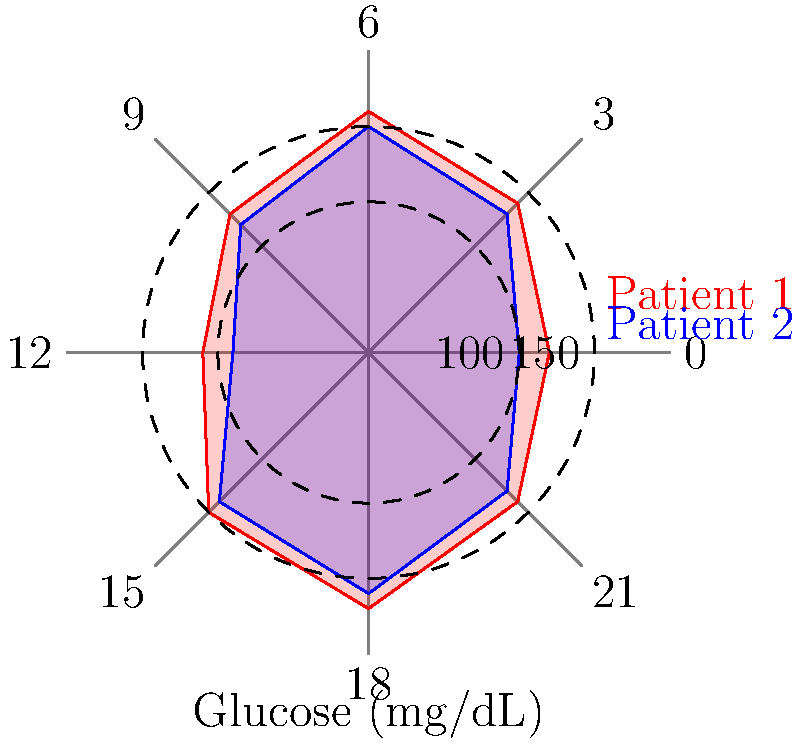As a computer science student helping patients set up health monitoring devices, you're tasked with interpreting glucose level data represented in a radial chart. The chart shows glucose levels for two patients throughout a 24-hour period. At what time does Patient 1 experience their highest glucose level, and what is the approximate value? To answer this question, we need to analyze the radial chart for Patient 1 (represented by the red line):

1. The chart is divided into 8 sections, each representing 3 hours in a 24-hour period.
2. The radial distance from the center represents the glucose level, with concentric circles marking 100 mg/dL and 150 mg/dL.
3. We need to identify the point where the red line (Patient 1) reaches its maximum distance from the center.

Looking at the chart:

1. The red line reaches its furthest point from the center between the 15 and 18-hour marks.
2. This corresponds to 6 PM (18:00) on a 24-hour clock.
3. The point extends beyond the 150 mg/dL circle but doesn't reach the edge of the chart (200 mg/dL).
4. We can estimate the value to be approximately 170 mg/dL.

Therefore, Patient 1's highest glucose level occurs at 18:00 (6 PM) and is approximately 170 mg/dL.
Answer: 18:00 (6 PM), ~170 mg/dL 